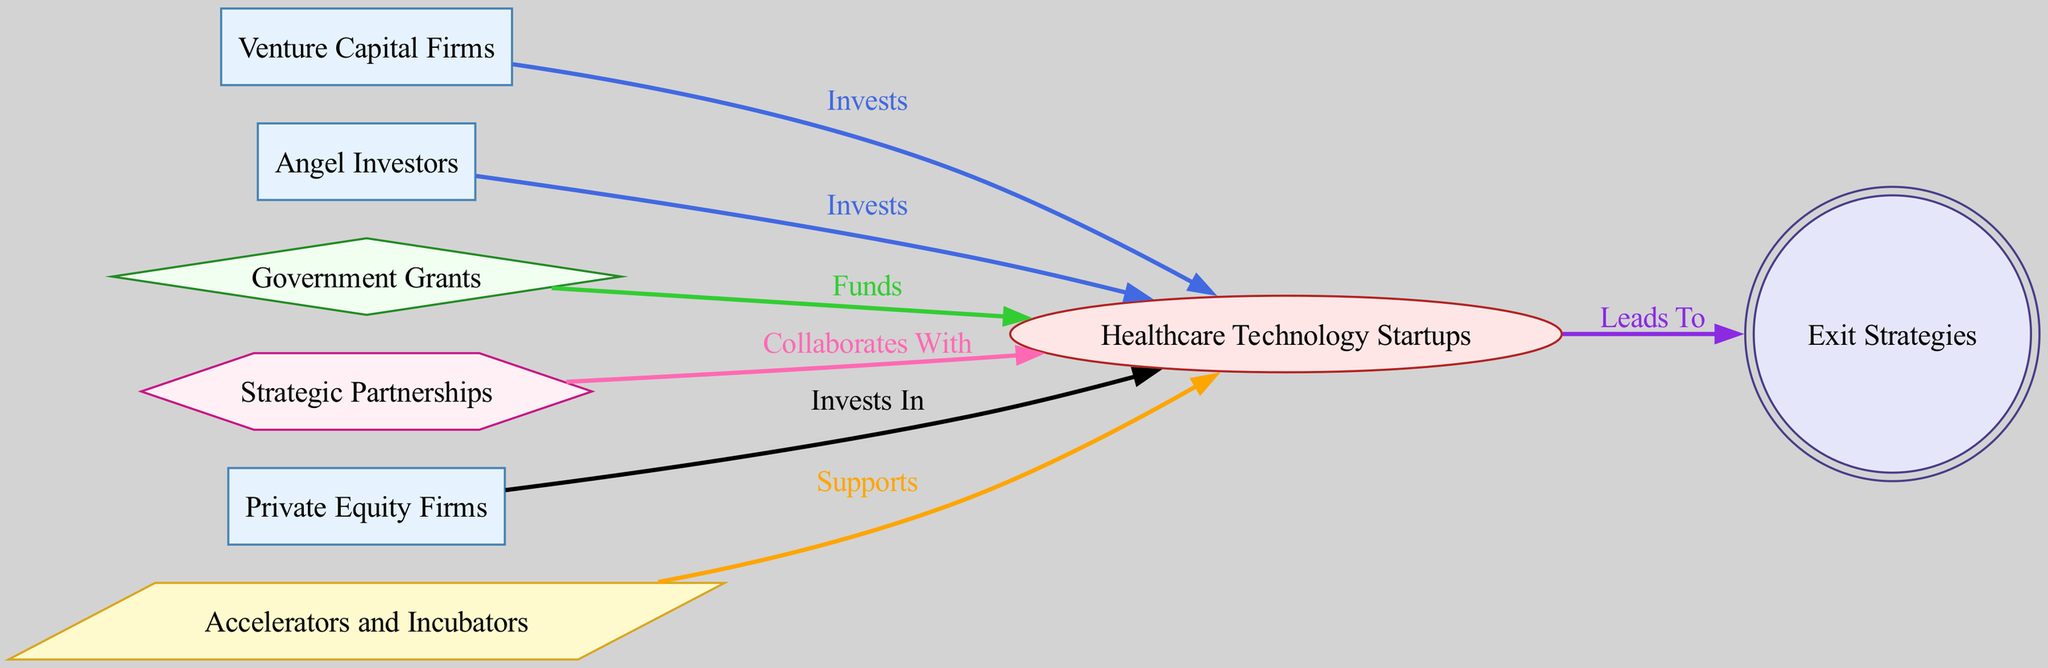What is the type of the node "C"? Node "C" is labeled as "Healthcare Technology Startups" and is described as an entity developing innovative healthcare solutions. According to the node types in the diagram, it is classified as an "Entity."
Answer: Entity How many investors are represented in the diagram? The diagram includes two investor nodes: "Venture Capital Firms" (A) and "Angel Investors" (B), along with "Private Equity Firms" (F). Adding these together gives a total of three investor nodes.
Answer: 3 Which funding source directly funds healthcare technology startups? The diagram identifies "Government Grants" (D) as a funding source that directly funds "Healthcare Technology Startups" (C), showing a directed relationship labeled "Funds."
Answer: Government Grants What is the outcome that healthcare technology startups lead to? The directed edge from "Healthcare Technology Startups" (C) to "Exit Strategies" (H) indicates that investments lead to specific outcomes, which are exit strategies like IPOs or acquisitions. Therefore, the outcome is "Exit Strategies."
Answer: Exit Strategies Which organization supports healthcare technology startups? The diagram shows "Accelerators and Incubators" (G) as a support organization with a directed relationship labeled "Supports," indicating they provide assistance to healthcare technology startups.
Answer: Accelerators and Incubators Which type of collaboration is depicted in this diagram? The directed relationship between "Strategic Partnerships" (E) and "Healthcare Technology Startups" (C) is labeled "Collaborates With," indicating that this type of collaboration occurs in the ecosystem.
Answer: Strategic Partnerships How many types of contributions are made to healthcare technology startups? The diagram shows multiple contributions in the form of investments (from A, B, and F), funding (from D), support (from G), and collaboration (from E). Altogether, there are five distinct types of contributions made to healthcare technology startups.
Answer: 5 What can be inferred about the flow of investment in this ecosystem? The directed edges indicate a flow where various entities—including investors, funding sources, and support organizations—link to healthcare technology startups. This signifies a collaborative and multifaceted approach to investment in the healthcare technology space.
Answer: Multi-faceted approach Which node type provides the most direct investments? The diagram illustrates that "Venture Capital Firms" (A), "Angel Investors" (B), and "Private Equity Firms" (F) all have direct investment relationships with healthcare technology startups (C). These three investor types provide the most direct investments, making "Investors" the node type with the most direct financial contributions.
Answer: Investors 